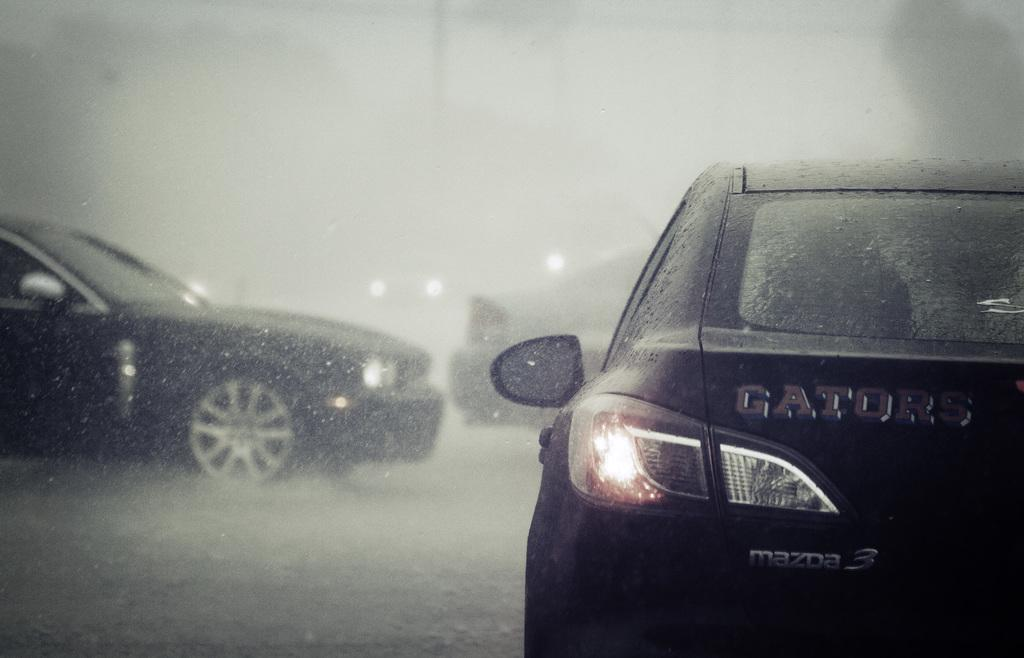What is the weather like in the image? It appears to be raining in the image. What can be seen on the road in the image? There are vehicles on the road. Can you describe the background of the image? The background is blurred. What type of kettle is being used in the argument in the image? There is no kettle or argument present in the image; it only shows rain and vehicles on the road. 